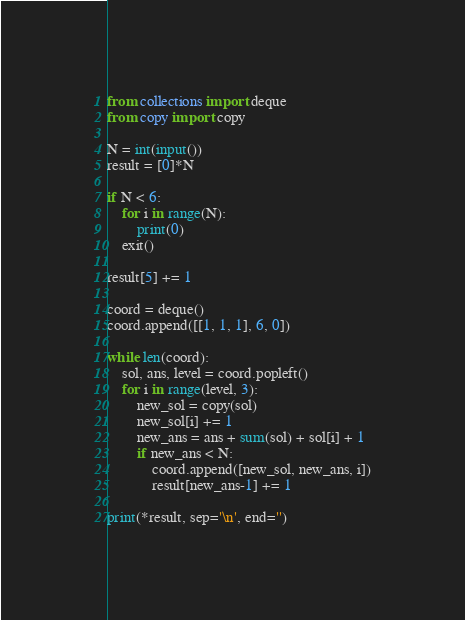Convert code to text. <code><loc_0><loc_0><loc_500><loc_500><_Python_>from collections import deque
from copy import copy

N = int(input())
result = [0]*N

if N < 6:
    for i in range(N):
        print(0)
    exit()

result[5] += 1

coord = deque()
coord.append([[1, 1, 1], 6, 0])

while len(coord):
    sol, ans, level = coord.popleft()
    for i in range(level, 3):
        new_sol = copy(sol)
        new_sol[i] += 1
        new_ans = ans + sum(sol) + sol[i] + 1
        if new_ans < N:
            coord.append([new_sol, new_ans, i])
            result[new_ans-1] += 1

print(*result, sep='\n', end='')

</code> 